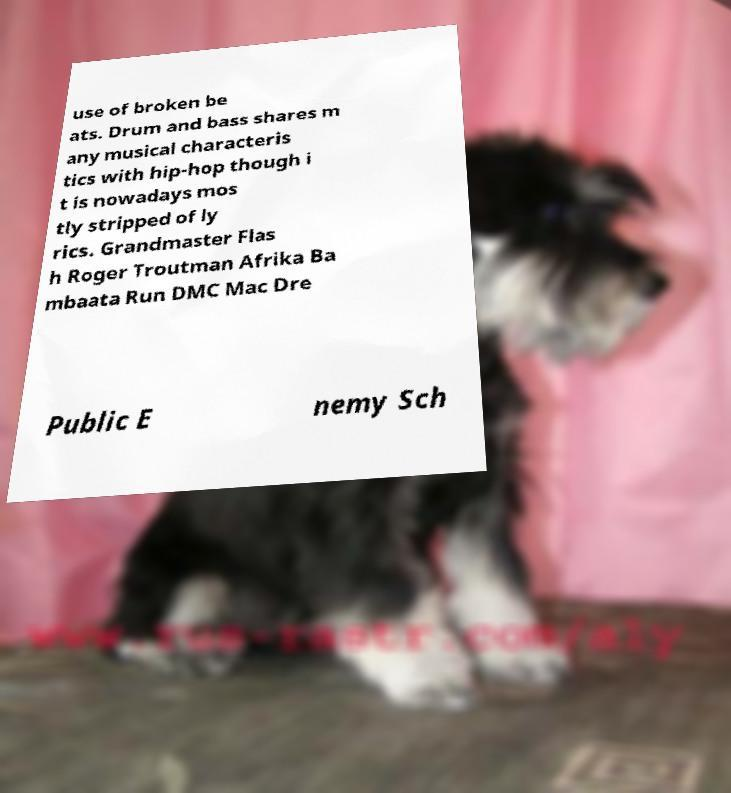Can you accurately transcribe the text from the provided image for me? use of broken be ats. Drum and bass shares m any musical characteris tics with hip-hop though i t is nowadays mos tly stripped of ly rics. Grandmaster Flas h Roger Troutman Afrika Ba mbaata Run DMC Mac Dre Public E nemy Sch 